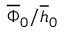<formula> <loc_0><loc_0><loc_500><loc_500>\overline { \Phi } _ { 0 } / \overline { h } _ { 0 }</formula> 